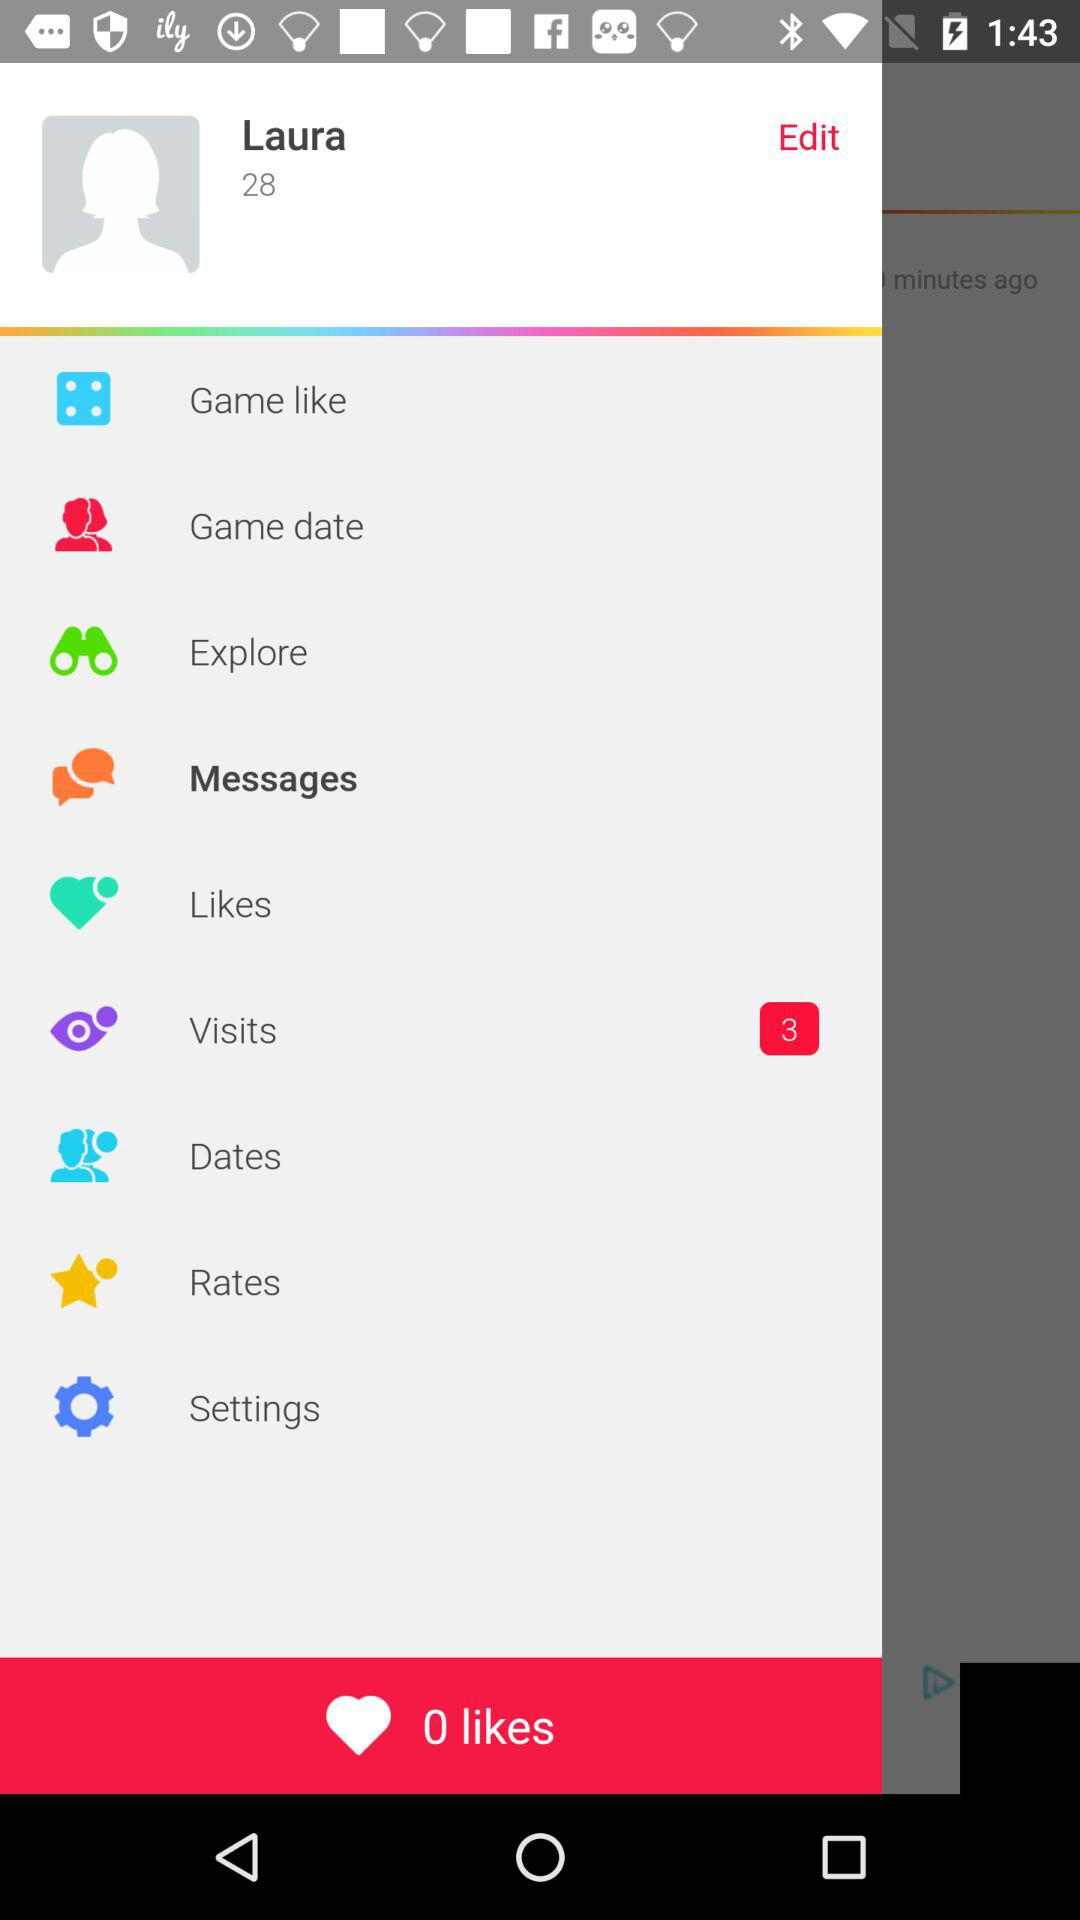What is the user name? The user name is Laura. 